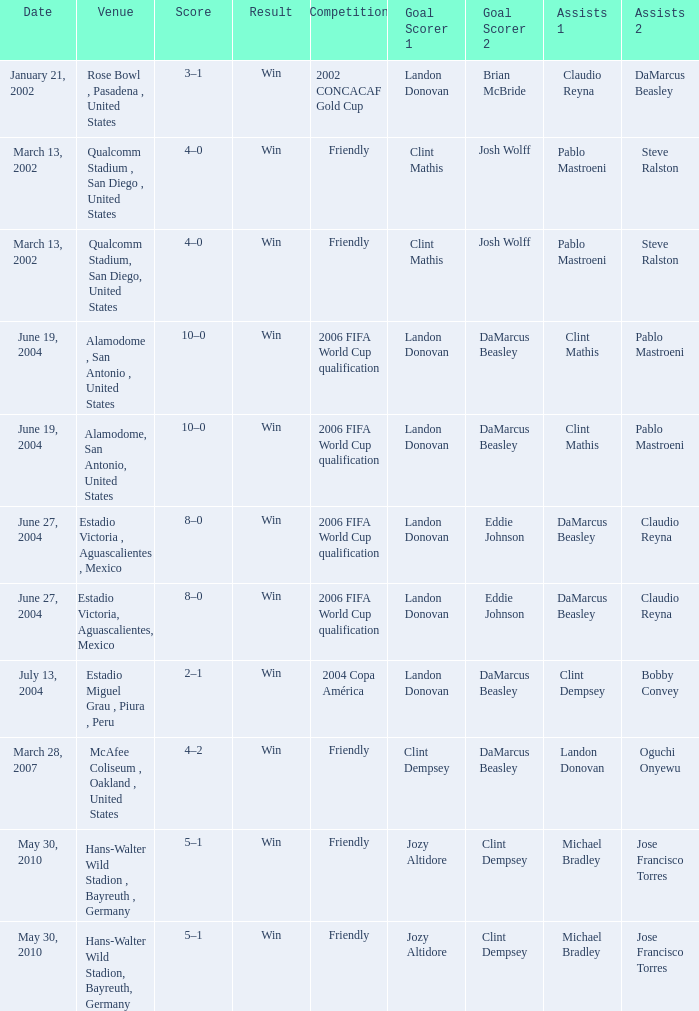What date has alamodome, san antonio, united states as the venue? June 19, 2004, June 19, 2004. 